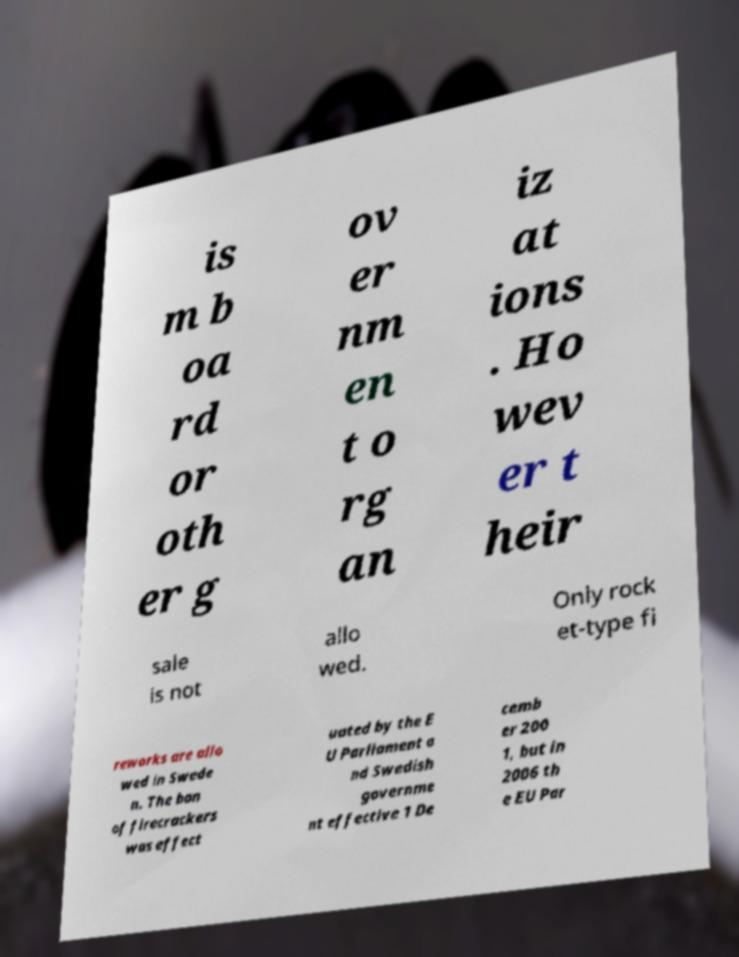I need the written content from this picture converted into text. Can you do that? is m b oa rd or oth er g ov er nm en t o rg an iz at ions . Ho wev er t heir sale is not allo wed. Only rock et-type fi reworks are allo wed in Swede n. The ban of firecrackers was effect uated by the E U Parliament a nd Swedish governme nt effective 1 De cemb er 200 1, but in 2006 th e EU Par 